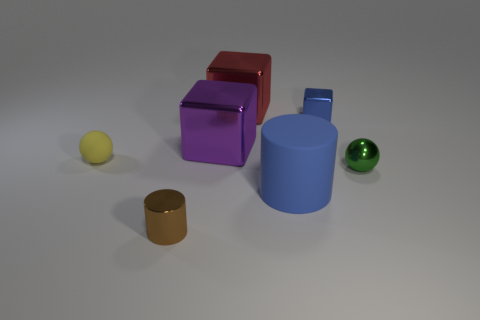Are there more red metallic things that are left of the tiny brown metal object than small brown objects?
Your answer should be very brief. No. Does the blue thing behind the green thing have the same size as the small yellow thing?
Your answer should be compact. Yes. There is a small shiny object that is both behind the blue matte cylinder and to the left of the green sphere; what color is it?
Make the answer very short. Blue. The blue thing that is the same size as the brown shiny cylinder is what shape?
Your response must be concise. Cube. Is there a big rubber object that has the same color as the matte cylinder?
Provide a succinct answer. No. Are there the same number of large red objects on the right side of the small green thing and big purple cubes?
Your answer should be compact. No. Is the color of the tiny shiny cube the same as the metallic ball?
Ensure brevity in your answer.  No. There is a object that is to the right of the purple shiny block and to the left of the blue matte object; what is its size?
Offer a very short reply. Large. There is a tiny cylinder that is made of the same material as the big purple cube; what is its color?
Make the answer very short. Brown. What number of brown blocks have the same material as the big red block?
Provide a short and direct response. 0. 